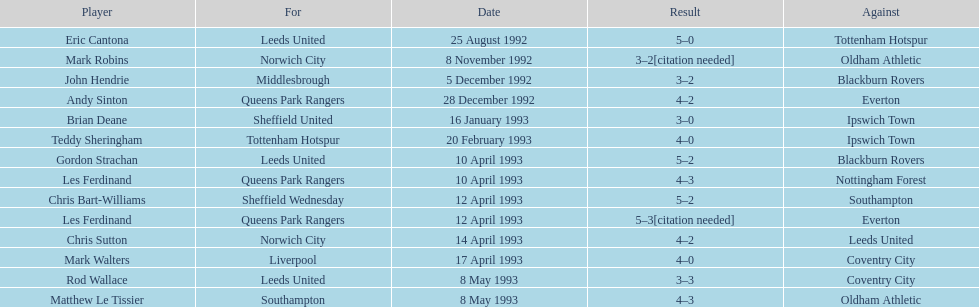In the 1992-1993 premier league, what was the total number of hat tricks scored by all players? 14. 